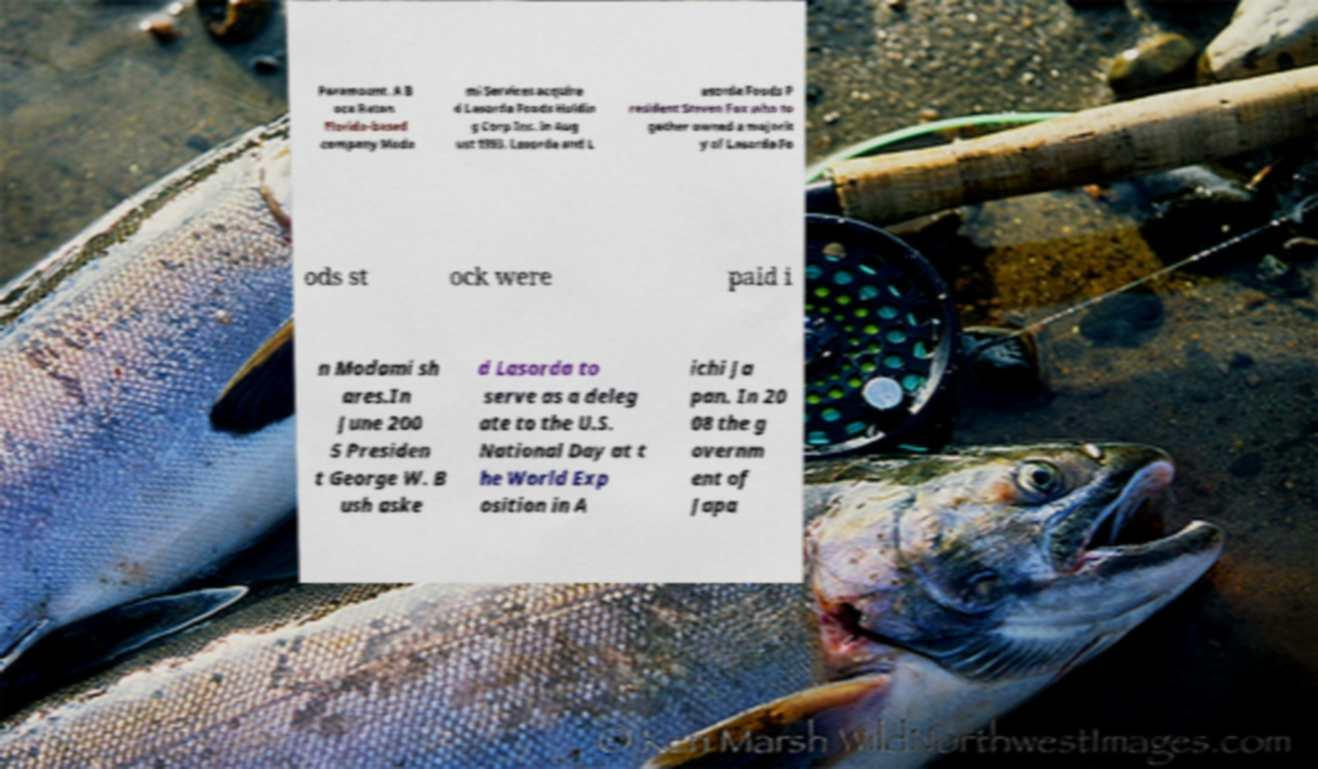Please identify and transcribe the text found in this image. Paramount. A B oca Raton Florida-based company Moda mi Services acquire d Lasorda Foods Holdin g Corp Inc. in Aug ust 1993. Lasorda and L asorda Foods P resident Steven Fox who to gether owned a majorit y of Lasorda Fo ods st ock were paid i n Modami sh ares.In June 200 5 Presiden t George W. B ush aske d Lasorda to serve as a deleg ate to the U.S. National Day at t he World Exp osition in A ichi Ja pan. In 20 08 the g overnm ent of Japa 